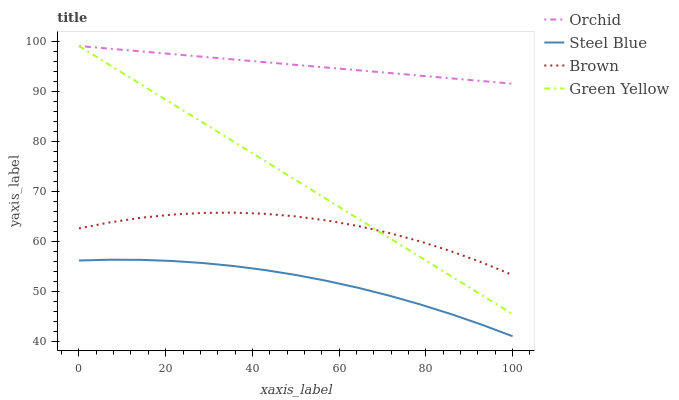Does Steel Blue have the minimum area under the curve?
Answer yes or no. Yes. Does Orchid have the maximum area under the curve?
Answer yes or no. Yes. Does Green Yellow have the minimum area under the curve?
Answer yes or no. No. Does Green Yellow have the maximum area under the curve?
Answer yes or no. No. Is Green Yellow the smoothest?
Answer yes or no. Yes. Is Brown the roughest?
Answer yes or no. Yes. Is Steel Blue the smoothest?
Answer yes or no. No. Is Steel Blue the roughest?
Answer yes or no. No. Does Steel Blue have the lowest value?
Answer yes or no. Yes. Does Green Yellow have the lowest value?
Answer yes or no. No. Does Orchid have the highest value?
Answer yes or no. Yes. Does Steel Blue have the highest value?
Answer yes or no. No. Is Steel Blue less than Green Yellow?
Answer yes or no. Yes. Is Orchid greater than Steel Blue?
Answer yes or no. Yes. Does Brown intersect Green Yellow?
Answer yes or no. Yes. Is Brown less than Green Yellow?
Answer yes or no. No. Is Brown greater than Green Yellow?
Answer yes or no. No. Does Steel Blue intersect Green Yellow?
Answer yes or no. No. 